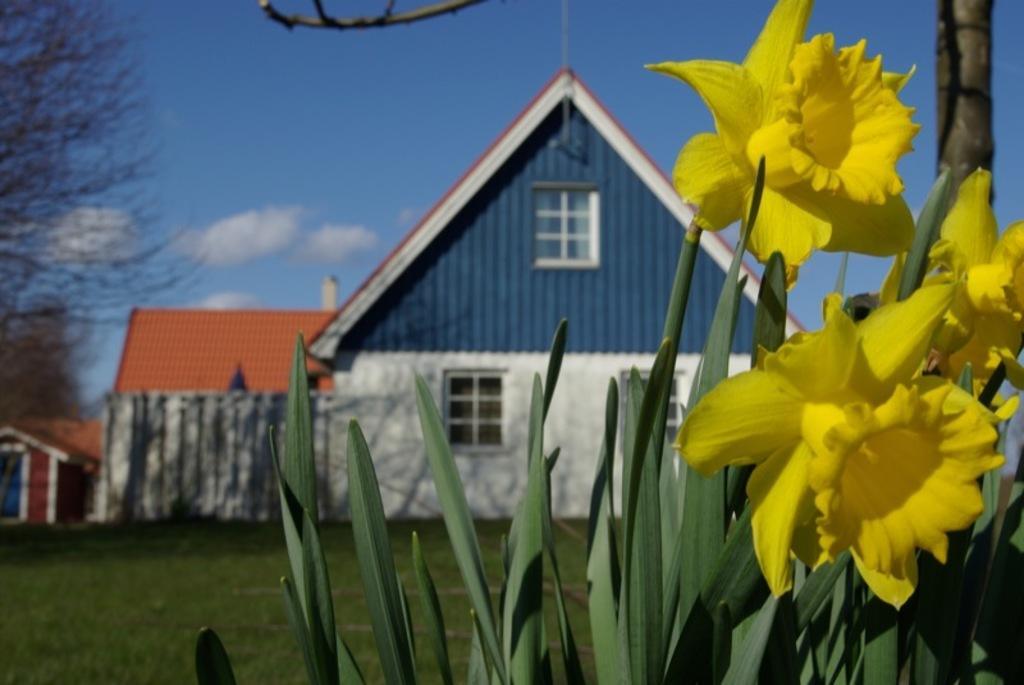Please provide a concise description of this image. In this image I can see few plants which are green in color and few flowers which are yellow in color. In the background I can see some grass, few buildings, a tree and the sky. 